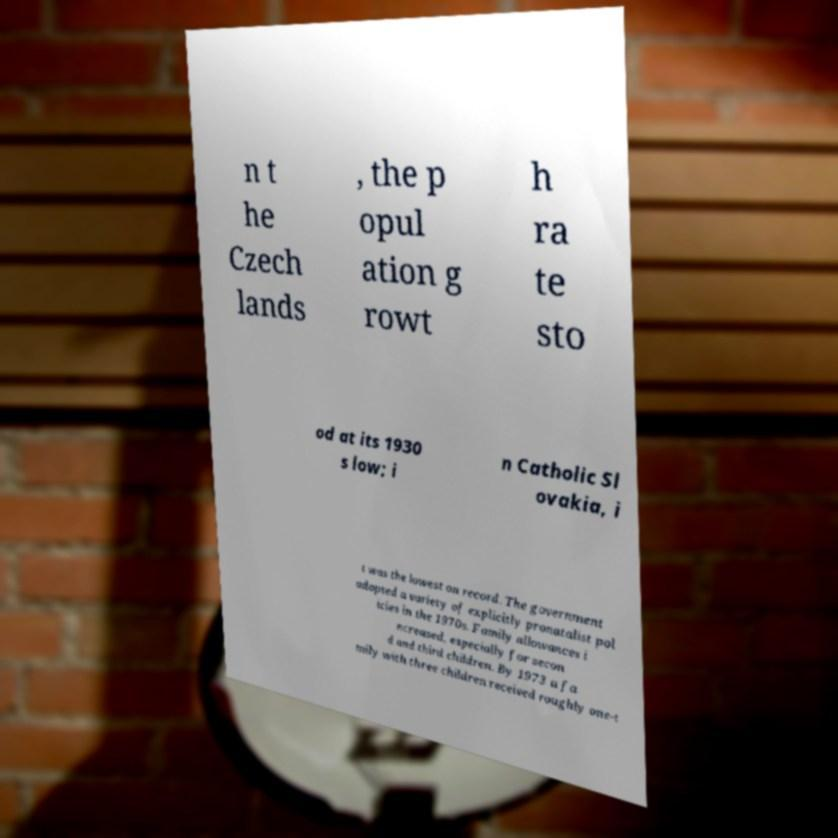For documentation purposes, I need the text within this image transcribed. Could you provide that? n t he Czech lands , the p opul ation g rowt h ra te sto od at its 1930 s low; i n Catholic Sl ovakia, i t was the lowest on record. The government adopted a variety of explicitly pronatalist pol icies in the 1970s. Family allowances i ncreased, especially for secon d and third children. By 1973 a fa mily with three children received roughly one-t 